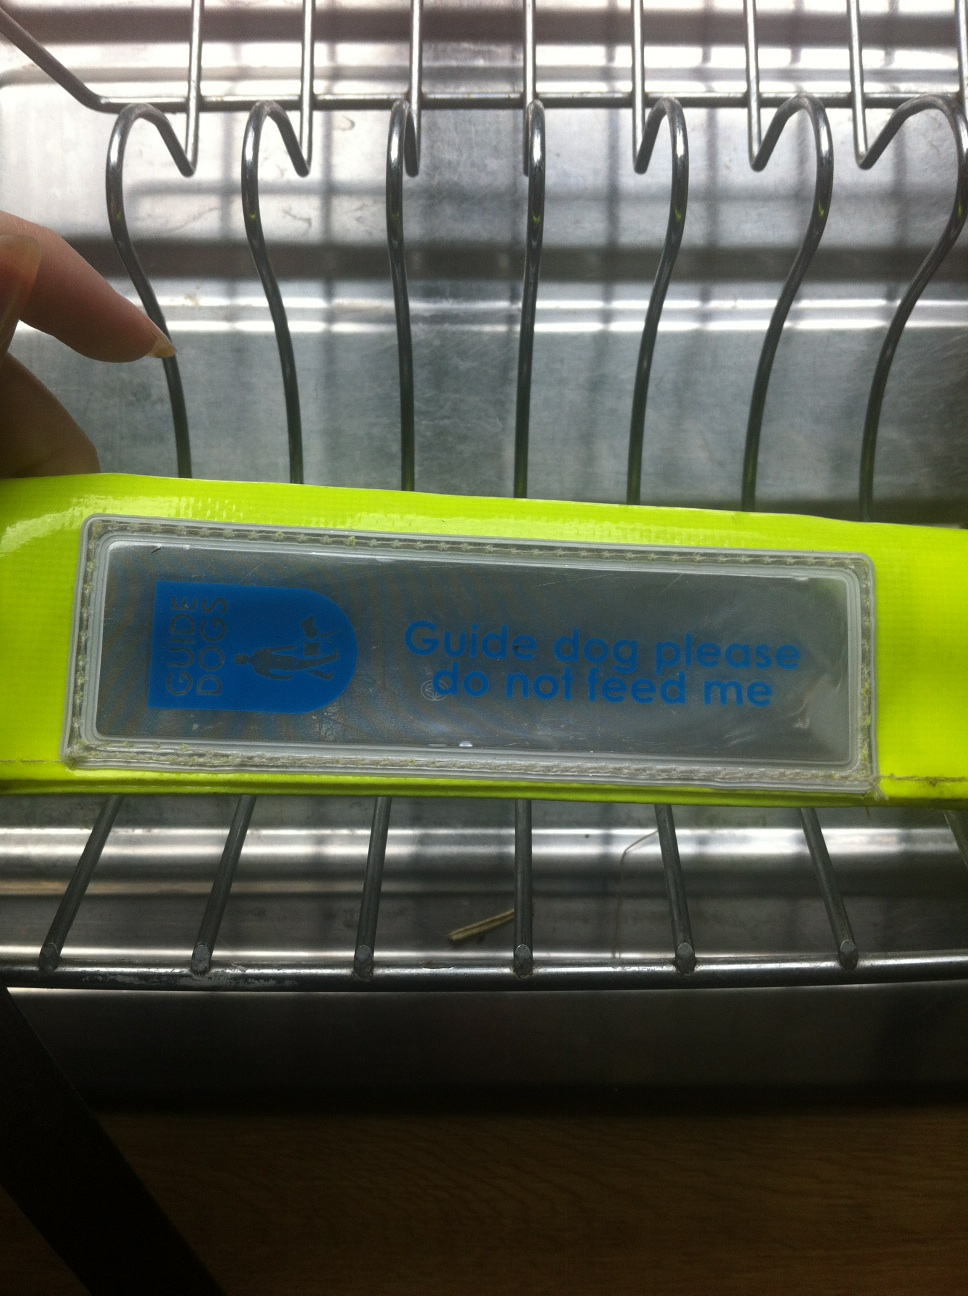Can you tell me more about guide dogs? Certainly! Guide dogs are trained service animals that help visually impaired individuals navigate their surroundings. They undergo rigorous training to learn how to safely lead their handler around obstacles and through various environments. It's essential not to feed or distract them because they need to be focused on their tasks to ensure their handler's safety. What kind of training does a guide dog go through? Guide dogs undergo training that includes obedience, mastering commands, learning to navigate busy streets, avoiding distractions, and understanding specific routes and tasks. This process often takes months and includes both instruction at a training facility and real-world exposure. Additionally, they are taught to judge height and width to ensure their handler can pass through safely. 